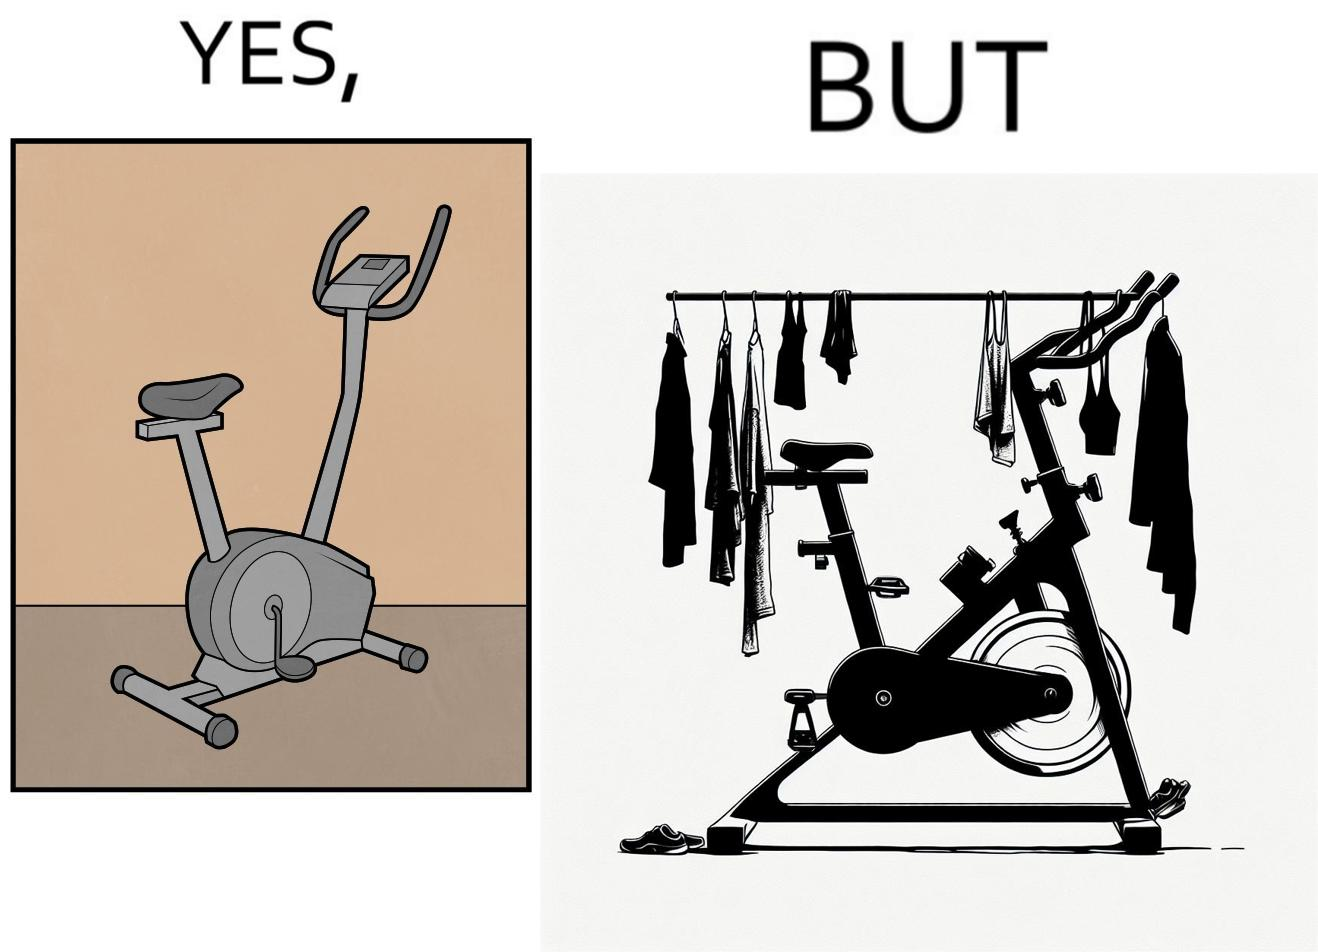Is there satirical content in this image? Yes, this image is satirical. 